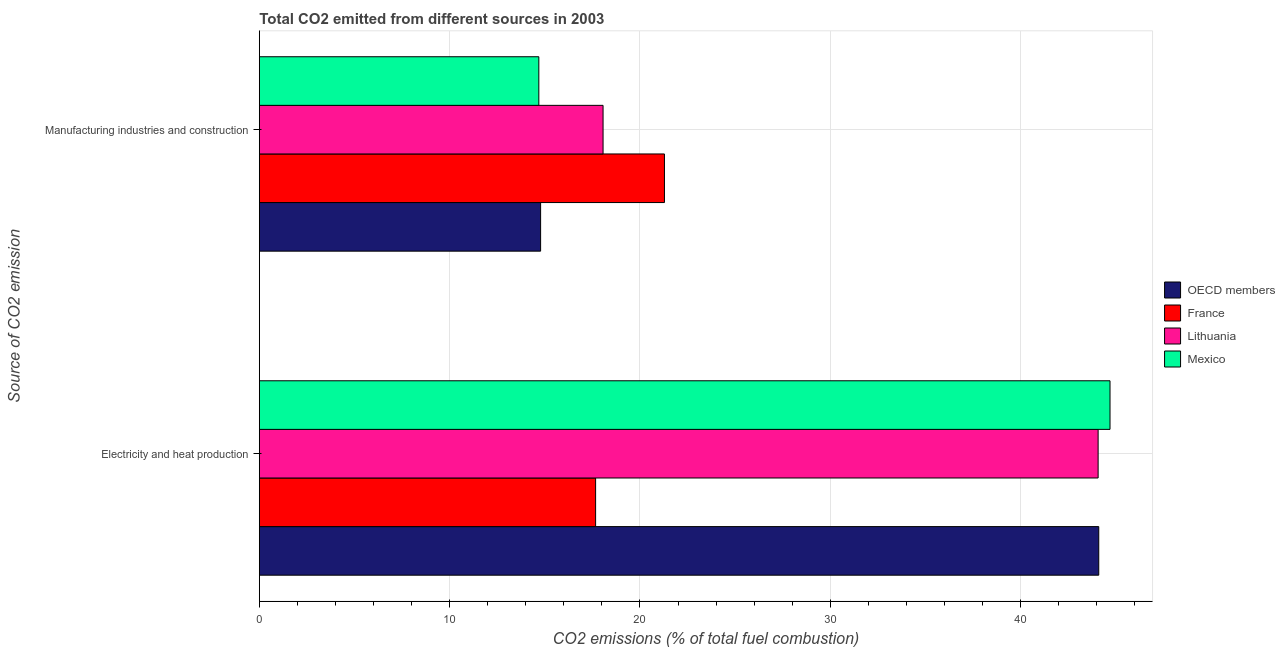How many bars are there on the 2nd tick from the top?
Provide a short and direct response. 4. What is the label of the 1st group of bars from the top?
Your answer should be very brief. Manufacturing industries and construction. What is the co2 emissions due to manufacturing industries in France?
Make the answer very short. 21.29. Across all countries, what is the maximum co2 emissions due to electricity and heat production?
Ensure brevity in your answer.  44.7. Across all countries, what is the minimum co2 emissions due to electricity and heat production?
Keep it short and to the point. 17.67. In which country was the co2 emissions due to electricity and heat production minimum?
Keep it short and to the point. France. What is the total co2 emissions due to electricity and heat production in the graph?
Your response must be concise. 150.56. What is the difference between the co2 emissions due to electricity and heat production in France and that in Lithuania?
Provide a succinct answer. -26.41. What is the difference between the co2 emissions due to manufacturing industries in Lithuania and the co2 emissions due to electricity and heat production in OECD members?
Ensure brevity in your answer.  -26.05. What is the average co2 emissions due to electricity and heat production per country?
Offer a terse response. 37.64. What is the difference between the co2 emissions due to manufacturing industries and co2 emissions due to electricity and heat production in Lithuania?
Provide a short and direct response. -26.01. In how many countries, is the co2 emissions due to manufacturing industries greater than 28 %?
Your answer should be very brief. 0. What is the ratio of the co2 emissions due to manufacturing industries in Mexico to that in OECD members?
Offer a terse response. 0.99. Is the co2 emissions due to manufacturing industries in France less than that in Lithuania?
Keep it short and to the point. No. In how many countries, is the co2 emissions due to electricity and heat production greater than the average co2 emissions due to electricity and heat production taken over all countries?
Offer a terse response. 3. What does the 3rd bar from the bottom in Electricity and heat production represents?
Give a very brief answer. Lithuania. Are all the bars in the graph horizontal?
Offer a very short reply. Yes. What is the difference between two consecutive major ticks on the X-axis?
Keep it short and to the point. 10. Does the graph contain any zero values?
Your answer should be very brief. No. Does the graph contain grids?
Offer a terse response. Yes. How are the legend labels stacked?
Ensure brevity in your answer.  Vertical. What is the title of the graph?
Offer a very short reply. Total CO2 emitted from different sources in 2003. What is the label or title of the X-axis?
Your answer should be very brief. CO2 emissions (% of total fuel combustion). What is the label or title of the Y-axis?
Your answer should be very brief. Source of CO2 emission. What is the CO2 emissions (% of total fuel combustion) of OECD members in Electricity and heat production?
Make the answer very short. 44.11. What is the CO2 emissions (% of total fuel combustion) in France in Electricity and heat production?
Keep it short and to the point. 17.67. What is the CO2 emissions (% of total fuel combustion) of Lithuania in Electricity and heat production?
Your answer should be compact. 44.08. What is the CO2 emissions (% of total fuel combustion) in Mexico in Electricity and heat production?
Provide a succinct answer. 44.7. What is the CO2 emissions (% of total fuel combustion) in OECD members in Manufacturing industries and construction?
Provide a short and direct response. 14.78. What is the CO2 emissions (% of total fuel combustion) of France in Manufacturing industries and construction?
Give a very brief answer. 21.29. What is the CO2 emissions (% of total fuel combustion) in Lithuania in Manufacturing industries and construction?
Offer a terse response. 18.06. What is the CO2 emissions (% of total fuel combustion) of Mexico in Manufacturing industries and construction?
Provide a short and direct response. 14.69. Across all Source of CO2 emission, what is the maximum CO2 emissions (% of total fuel combustion) in OECD members?
Ensure brevity in your answer.  44.11. Across all Source of CO2 emission, what is the maximum CO2 emissions (% of total fuel combustion) of France?
Ensure brevity in your answer.  21.29. Across all Source of CO2 emission, what is the maximum CO2 emissions (% of total fuel combustion) of Lithuania?
Provide a succinct answer. 44.08. Across all Source of CO2 emission, what is the maximum CO2 emissions (% of total fuel combustion) of Mexico?
Provide a short and direct response. 44.7. Across all Source of CO2 emission, what is the minimum CO2 emissions (% of total fuel combustion) in OECD members?
Provide a succinct answer. 14.78. Across all Source of CO2 emission, what is the minimum CO2 emissions (% of total fuel combustion) in France?
Provide a succinct answer. 17.67. Across all Source of CO2 emission, what is the minimum CO2 emissions (% of total fuel combustion) in Lithuania?
Ensure brevity in your answer.  18.06. Across all Source of CO2 emission, what is the minimum CO2 emissions (% of total fuel combustion) in Mexico?
Keep it short and to the point. 14.69. What is the total CO2 emissions (% of total fuel combustion) of OECD members in the graph?
Your answer should be compact. 58.89. What is the total CO2 emissions (% of total fuel combustion) in France in the graph?
Your response must be concise. 38.96. What is the total CO2 emissions (% of total fuel combustion) of Lithuania in the graph?
Offer a terse response. 62.14. What is the total CO2 emissions (% of total fuel combustion) of Mexico in the graph?
Make the answer very short. 59.39. What is the difference between the CO2 emissions (% of total fuel combustion) in OECD members in Electricity and heat production and that in Manufacturing industries and construction?
Make the answer very short. 29.33. What is the difference between the CO2 emissions (% of total fuel combustion) of France in Electricity and heat production and that in Manufacturing industries and construction?
Your answer should be very brief. -3.62. What is the difference between the CO2 emissions (% of total fuel combustion) of Lithuania in Electricity and heat production and that in Manufacturing industries and construction?
Your answer should be compact. 26.01. What is the difference between the CO2 emissions (% of total fuel combustion) of Mexico in Electricity and heat production and that in Manufacturing industries and construction?
Provide a succinct answer. 30.01. What is the difference between the CO2 emissions (% of total fuel combustion) in OECD members in Electricity and heat production and the CO2 emissions (% of total fuel combustion) in France in Manufacturing industries and construction?
Your response must be concise. 22.82. What is the difference between the CO2 emissions (% of total fuel combustion) of OECD members in Electricity and heat production and the CO2 emissions (% of total fuel combustion) of Lithuania in Manufacturing industries and construction?
Make the answer very short. 26.05. What is the difference between the CO2 emissions (% of total fuel combustion) of OECD members in Electricity and heat production and the CO2 emissions (% of total fuel combustion) of Mexico in Manufacturing industries and construction?
Your response must be concise. 29.42. What is the difference between the CO2 emissions (% of total fuel combustion) of France in Electricity and heat production and the CO2 emissions (% of total fuel combustion) of Lithuania in Manufacturing industries and construction?
Offer a terse response. -0.39. What is the difference between the CO2 emissions (% of total fuel combustion) in France in Electricity and heat production and the CO2 emissions (% of total fuel combustion) in Mexico in Manufacturing industries and construction?
Provide a succinct answer. 2.98. What is the difference between the CO2 emissions (% of total fuel combustion) of Lithuania in Electricity and heat production and the CO2 emissions (% of total fuel combustion) of Mexico in Manufacturing industries and construction?
Provide a succinct answer. 29.39. What is the average CO2 emissions (% of total fuel combustion) in OECD members per Source of CO2 emission?
Give a very brief answer. 29.44. What is the average CO2 emissions (% of total fuel combustion) in France per Source of CO2 emission?
Provide a short and direct response. 19.48. What is the average CO2 emissions (% of total fuel combustion) in Lithuania per Source of CO2 emission?
Provide a succinct answer. 31.07. What is the average CO2 emissions (% of total fuel combustion) of Mexico per Source of CO2 emission?
Make the answer very short. 29.69. What is the difference between the CO2 emissions (% of total fuel combustion) in OECD members and CO2 emissions (% of total fuel combustion) in France in Electricity and heat production?
Offer a terse response. 26.44. What is the difference between the CO2 emissions (% of total fuel combustion) of OECD members and CO2 emissions (% of total fuel combustion) of Lithuania in Electricity and heat production?
Give a very brief answer. 0.03. What is the difference between the CO2 emissions (% of total fuel combustion) of OECD members and CO2 emissions (% of total fuel combustion) of Mexico in Electricity and heat production?
Your response must be concise. -0.59. What is the difference between the CO2 emissions (% of total fuel combustion) of France and CO2 emissions (% of total fuel combustion) of Lithuania in Electricity and heat production?
Offer a terse response. -26.41. What is the difference between the CO2 emissions (% of total fuel combustion) in France and CO2 emissions (% of total fuel combustion) in Mexico in Electricity and heat production?
Ensure brevity in your answer.  -27.03. What is the difference between the CO2 emissions (% of total fuel combustion) of Lithuania and CO2 emissions (% of total fuel combustion) of Mexico in Electricity and heat production?
Offer a very short reply. -0.62. What is the difference between the CO2 emissions (% of total fuel combustion) of OECD members and CO2 emissions (% of total fuel combustion) of France in Manufacturing industries and construction?
Your answer should be very brief. -6.51. What is the difference between the CO2 emissions (% of total fuel combustion) in OECD members and CO2 emissions (% of total fuel combustion) in Lithuania in Manufacturing industries and construction?
Your answer should be compact. -3.28. What is the difference between the CO2 emissions (% of total fuel combustion) in OECD members and CO2 emissions (% of total fuel combustion) in Mexico in Manufacturing industries and construction?
Give a very brief answer. 0.09. What is the difference between the CO2 emissions (% of total fuel combustion) in France and CO2 emissions (% of total fuel combustion) in Lithuania in Manufacturing industries and construction?
Ensure brevity in your answer.  3.23. What is the difference between the CO2 emissions (% of total fuel combustion) in France and CO2 emissions (% of total fuel combustion) in Mexico in Manufacturing industries and construction?
Provide a succinct answer. 6.6. What is the difference between the CO2 emissions (% of total fuel combustion) of Lithuania and CO2 emissions (% of total fuel combustion) of Mexico in Manufacturing industries and construction?
Make the answer very short. 3.37. What is the ratio of the CO2 emissions (% of total fuel combustion) in OECD members in Electricity and heat production to that in Manufacturing industries and construction?
Make the answer very short. 2.98. What is the ratio of the CO2 emissions (% of total fuel combustion) in France in Electricity and heat production to that in Manufacturing industries and construction?
Your answer should be compact. 0.83. What is the ratio of the CO2 emissions (% of total fuel combustion) of Lithuania in Electricity and heat production to that in Manufacturing industries and construction?
Your answer should be compact. 2.44. What is the ratio of the CO2 emissions (% of total fuel combustion) in Mexico in Electricity and heat production to that in Manufacturing industries and construction?
Offer a terse response. 3.04. What is the difference between the highest and the second highest CO2 emissions (% of total fuel combustion) of OECD members?
Your answer should be compact. 29.33. What is the difference between the highest and the second highest CO2 emissions (% of total fuel combustion) in France?
Offer a terse response. 3.62. What is the difference between the highest and the second highest CO2 emissions (% of total fuel combustion) in Lithuania?
Your response must be concise. 26.01. What is the difference between the highest and the second highest CO2 emissions (% of total fuel combustion) of Mexico?
Keep it short and to the point. 30.01. What is the difference between the highest and the lowest CO2 emissions (% of total fuel combustion) of OECD members?
Offer a very short reply. 29.33. What is the difference between the highest and the lowest CO2 emissions (% of total fuel combustion) of France?
Provide a succinct answer. 3.62. What is the difference between the highest and the lowest CO2 emissions (% of total fuel combustion) of Lithuania?
Offer a very short reply. 26.01. What is the difference between the highest and the lowest CO2 emissions (% of total fuel combustion) of Mexico?
Give a very brief answer. 30.01. 